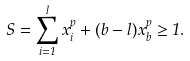<formula> <loc_0><loc_0><loc_500><loc_500>S = \sum _ { i = 1 } ^ { l } x _ { i } ^ { p } + ( b - l ) x _ { b } ^ { p } \geq 1 .</formula> 